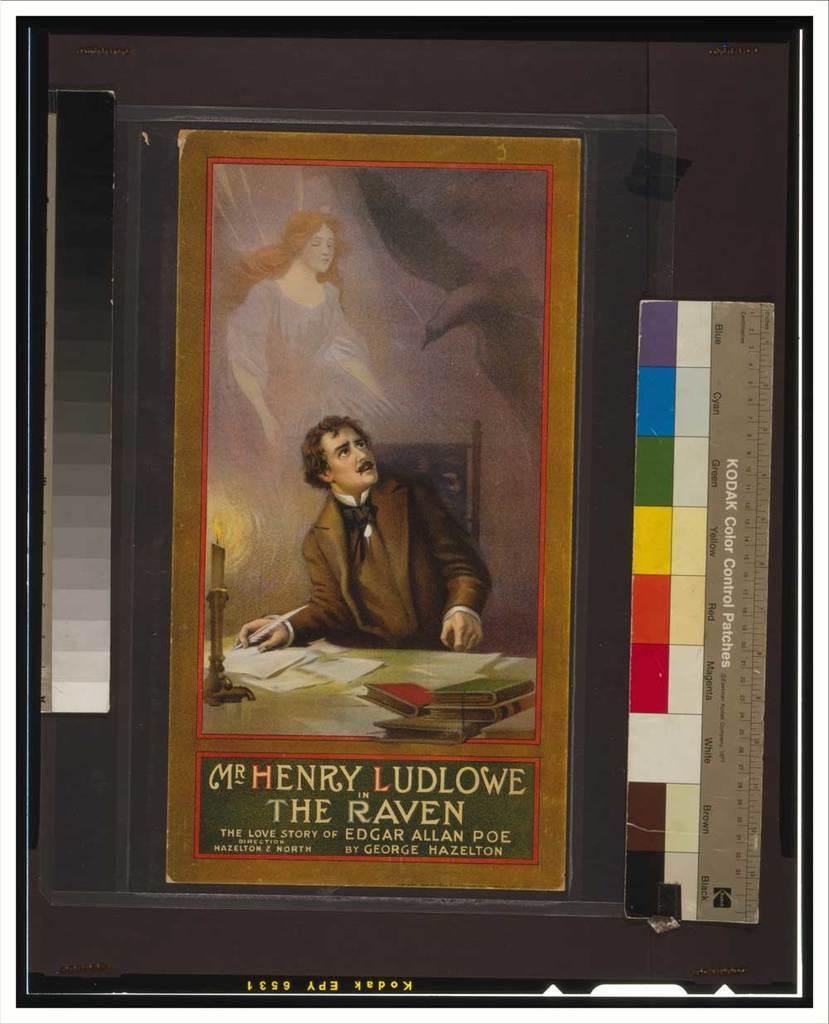Could you give a brief overview of what you see in this image? In this image there is a book, on that book there are pictures at the bottom there is text, on the right side and left side there are color scales, at the bottom there is text. 